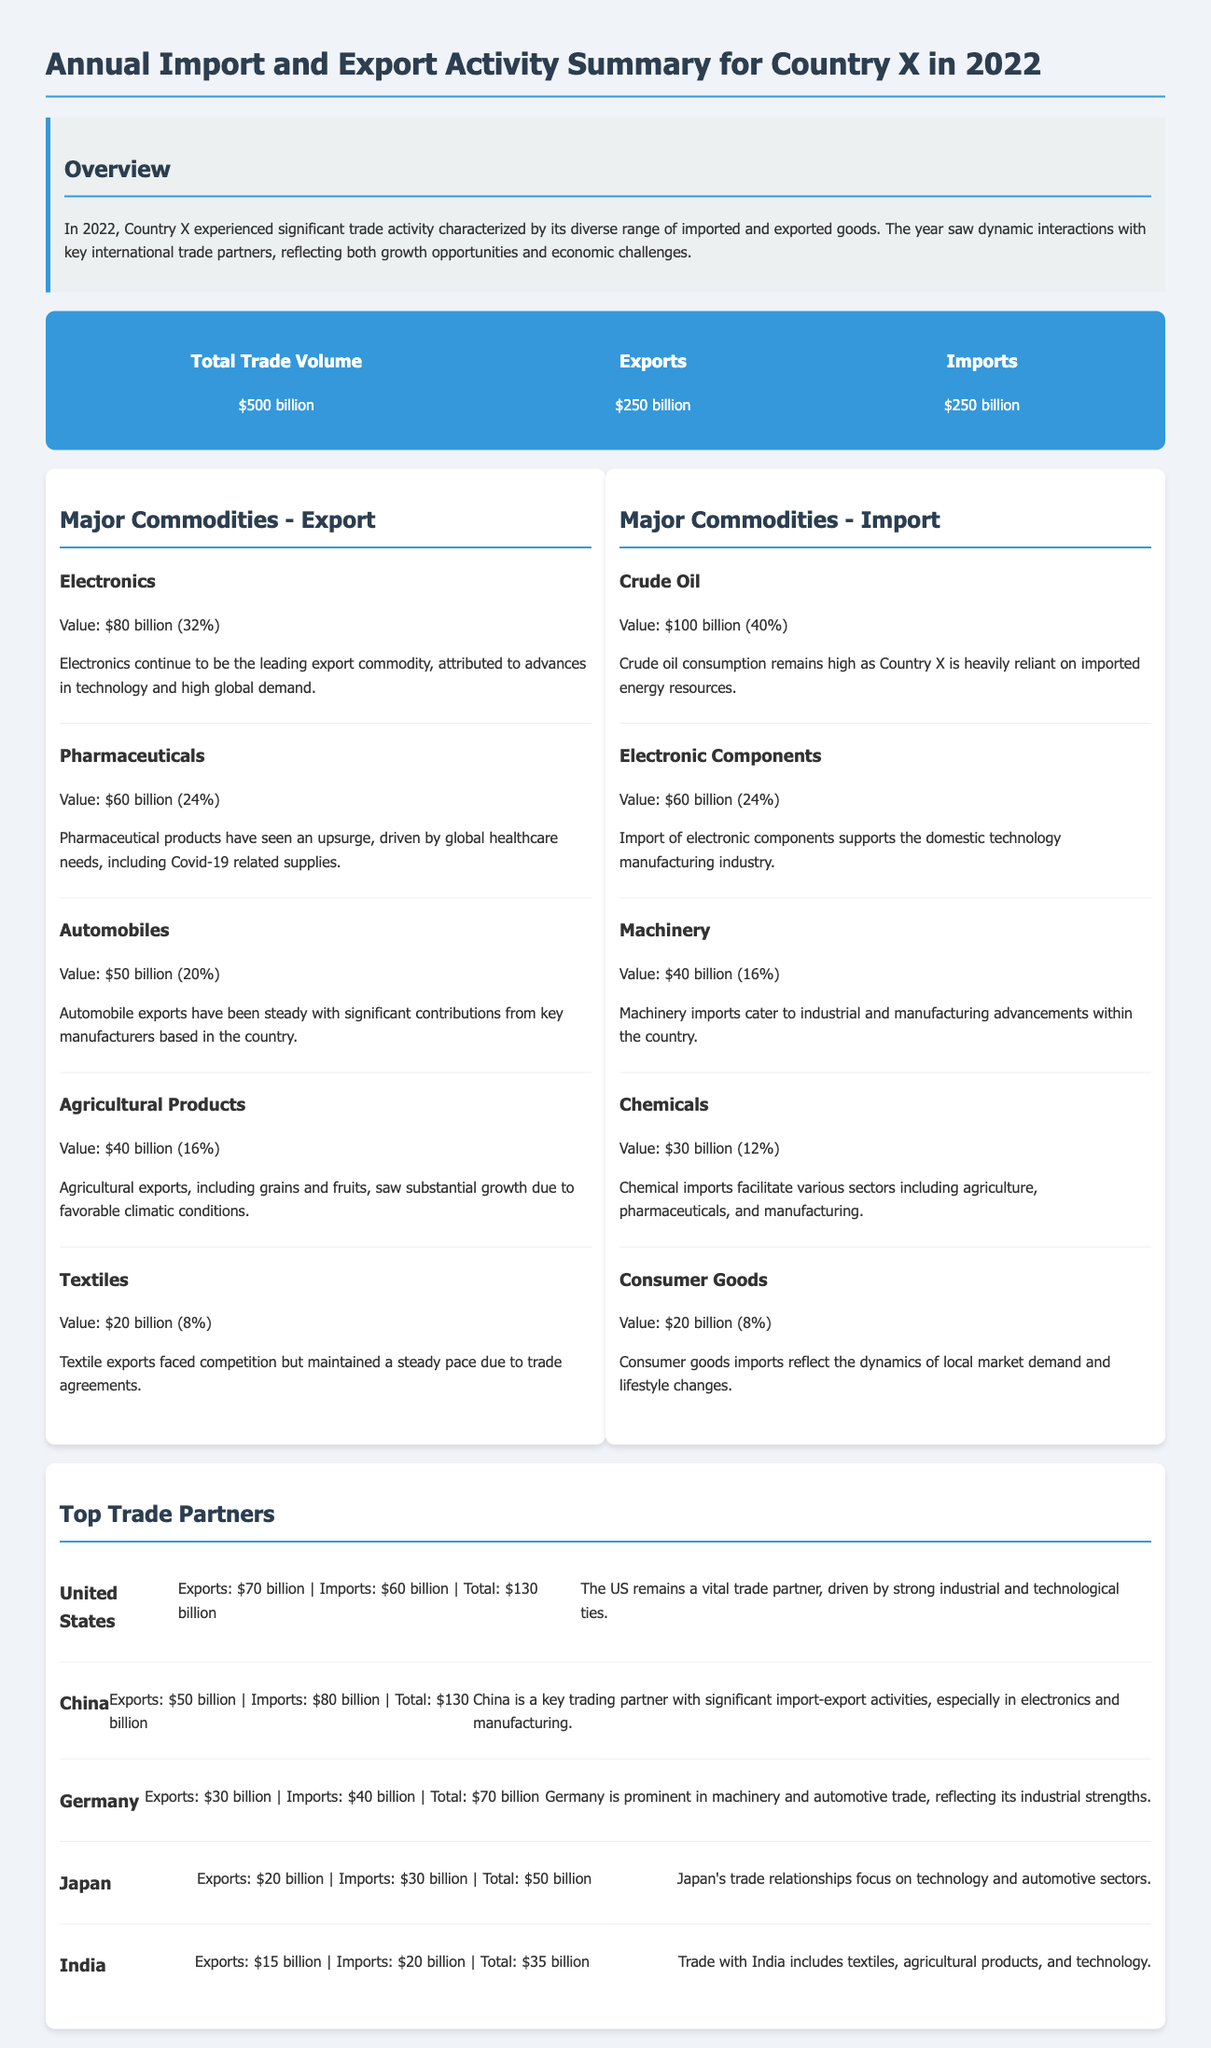What was the total trade volume for Country X in 2022? The total trade volume is mentioned in the document as $500 billion.
Answer: $500 billion What percentage of exports comes from Electronics? The document states that Electronics represent 32% of exports.
Answer: 32% Which commodity had the highest import value? The document identifies Crude Oil as the commodity with the highest import value at $100 billion.
Answer: Crude Oil Who are the top trade partners mentioned in the document? The document lists the United States, China, Germany, Japan, and India as the top trade partners.
Answer: United States, China, Germany, Japan, India What was the export value for Pharmaceuticals? The export value for Pharmaceuticals is noted to be $60 billion.
Answer: $60 billion How much did Country X export to China? The document shows that Country X exported $50 billion worth of goods to China.
Answer: $50 billion What proportion of total imports does Electronic Components represent? Electronic Components accounted for 24% of the total imports.
Answer: 24% Which trade partner accounted for the highest total trade activity? The document indicates that both the United States and China had a total trade activity of $130 billion, tying for the highest.
Answer: United States, China What was the value of Textile exports? The value of Textile exports is stated as $20 billion.
Answer: $20 billion 